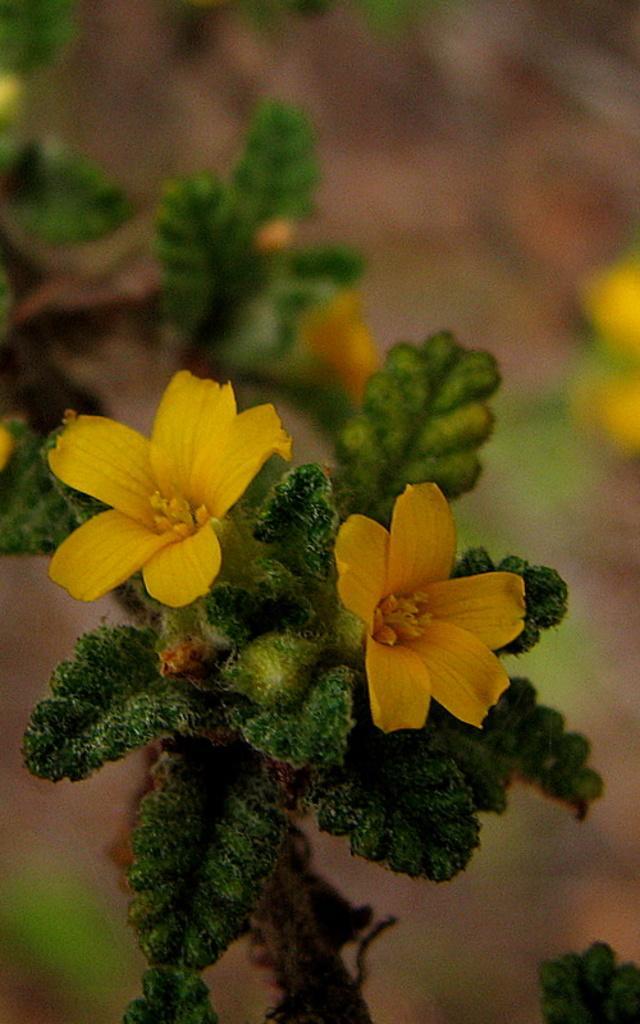Describe this image in one or two sentences. There is a plant. Which is having yellow color flowers. And the background is blurred. 